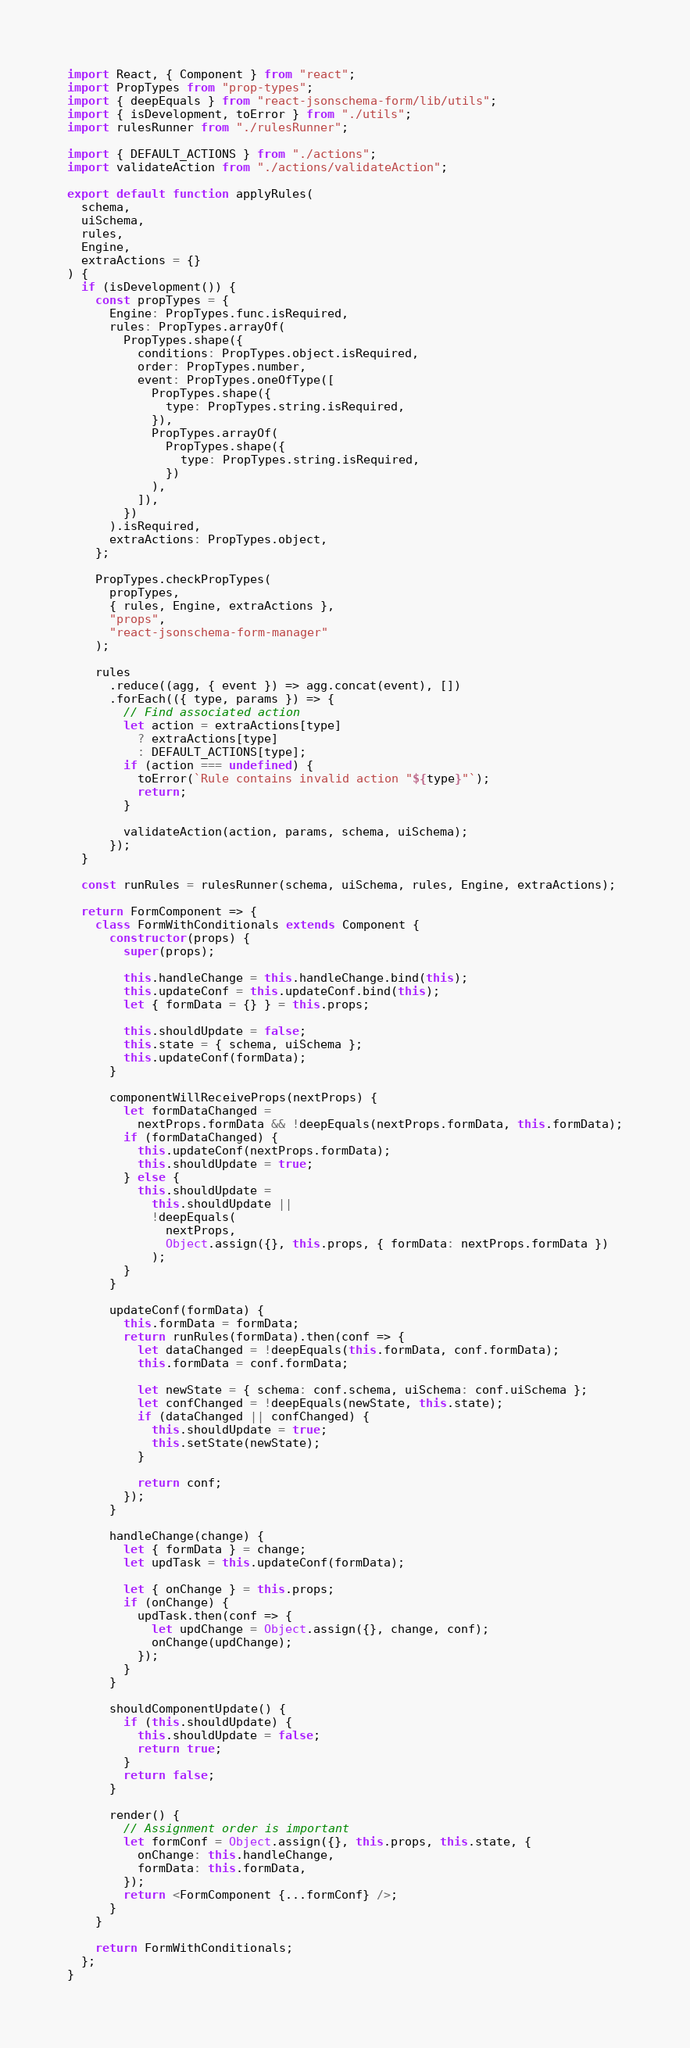Convert code to text. <code><loc_0><loc_0><loc_500><loc_500><_JavaScript_>import React, { Component } from "react";
import PropTypes from "prop-types";
import { deepEquals } from "react-jsonschema-form/lib/utils";
import { isDevelopment, toError } from "./utils";
import rulesRunner from "./rulesRunner";

import { DEFAULT_ACTIONS } from "./actions";
import validateAction from "./actions/validateAction";

export default function applyRules(
  schema,
  uiSchema,
  rules,
  Engine,
  extraActions = {}
) {
  if (isDevelopment()) {
    const propTypes = {
      Engine: PropTypes.func.isRequired,
      rules: PropTypes.arrayOf(
        PropTypes.shape({
          conditions: PropTypes.object.isRequired,
          order: PropTypes.number,
          event: PropTypes.oneOfType([
            PropTypes.shape({
              type: PropTypes.string.isRequired,
            }),
            PropTypes.arrayOf(
              PropTypes.shape({
                type: PropTypes.string.isRequired,
              })
            ),
          ]),
        })
      ).isRequired,
      extraActions: PropTypes.object,
    };

    PropTypes.checkPropTypes(
      propTypes,
      { rules, Engine, extraActions },
      "props",
      "react-jsonschema-form-manager"
    );

    rules
      .reduce((agg, { event }) => agg.concat(event), [])
      .forEach(({ type, params }) => {
        // Find associated action
        let action = extraActions[type]
          ? extraActions[type]
          : DEFAULT_ACTIONS[type];
        if (action === undefined) {
          toError(`Rule contains invalid action "${type}"`);
          return;
        }

        validateAction(action, params, schema, uiSchema);
      });
  }

  const runRules = rulesRunner(schema, uiSchema, rules, Engine, extraActions);

  return FormComponent => {
    class FormWithConditionals extends Component {
      constructor(props) {
        super(props);

        this.handleChange = this.handleChange.bind(this);
        this.updateConf = this.updateConf.bind(this);
        let { formData = {} } = this.props;

        this.shouldUpdate = false;
        this.state = { schema, uiSchema };
        this.updateConf(formData);
      }

      componentWillReceiveProps(nextProps) {
        let formDataChanged =
          nextProps.formData && !deepEquals(nextProps.formData, this.formData);
        if (formDataChanged) {
          this.updateConf(nextProps.formData);
          this.shouldUpdate = true;
        } else {
          this.shouldUpdate =
            this.shouldUpdate ||
            !deepEquals(
              nextProps,
              Object.assign({}, this.props, { formData: nextProps.formData })
            );
        }
      }

      updateConf(formData) {
        this.formData = formData;
        return runRules(formData).then(conf => {
          let dataChanged = !deepEquals(this.formData, conf.formData);
          this.formData = conf.formData;

          let newState = { schema: conf.schema, uiSchema: conf.uiSchema };
          let confChanged = !deepEquals(newState, this.state);
          if (dataChanged || confChanged) {
            this.shouldUpdate = true;
            this.setState(newState);
          }

          return conf;
        });
      }

      handleChange(change) {
        let { formData } = change;
        let updTask = this.updateConf(formData);

        let { onChange } = this.props;
        if (onChange) {
          updTask.then(conf => {
            let updChange = Object.assign({}, change, conf);
            onChange(updChange);
          });
        }
      }

      shouldComponentUpdate() {
        if (this.shouldUpdate) {
          this.shouldUpdate = false;
          return true;
        }
        return false;
      }

      render() {
        // Assignment order is important
        let formConf = Object.assign({}, this.props, this.state, {
          onChange: this.handleChange,
          formData: this.formData,
        });
        return <FormComponent {...formConf} />;
      }
    }

    return FormWithConditionals;
  };
}
</code> 